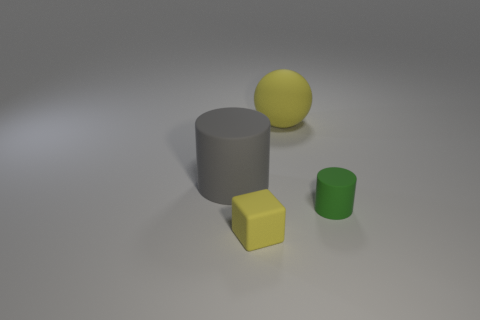Are there more big gray things that are right of the large matte cylinder than yellow rubber blocks on the left side of the rubber sphere? Upon evaluating the image, we do not observe any big gray objects to the right of the matte gray cylinder that outnumber the yellow rubber blocks on the left side of the rubber sphere, as there is just one large yellow rubber block visible. 